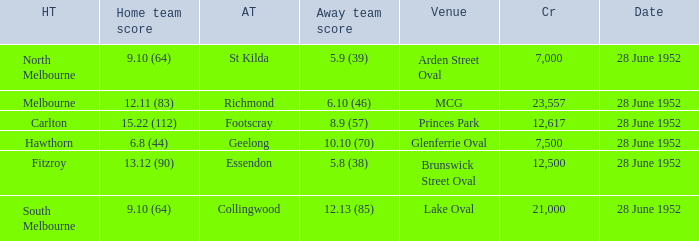Who is the away side when north melbourne is at home and has a score of 9.10 (64)? St Kilda. 